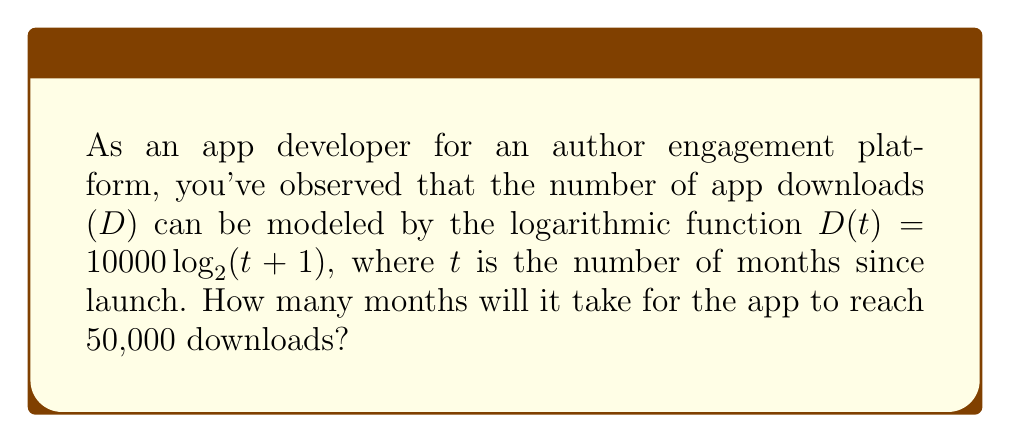Teach me how to tackle this problem. Let's approach this step-by-step:

1) We're given the function $D(t) = 10000 \log_2(t+1)$, where D is the number of downloads and t is the number of months.

2) We want to find t when D = 50,000. So, let's set up the equation:
   
   $50000 = 10000 \log_2(t+1)$

3) Divide both sides by 10000:
   
   $5 = \log_2(t+1)$

4) To solve for t, we need to apply the inverse function (exponential) to both sides:
   
   $2^5 = t+1$

5) Simplify the left side:
   
   $32 = t+1$

6) Subtract 1 from both sides to isolate t:
   
   $31 = t$

Therefore, it will take 31 months for the app to reach 50,000 downloads.
Answer: 31 months 